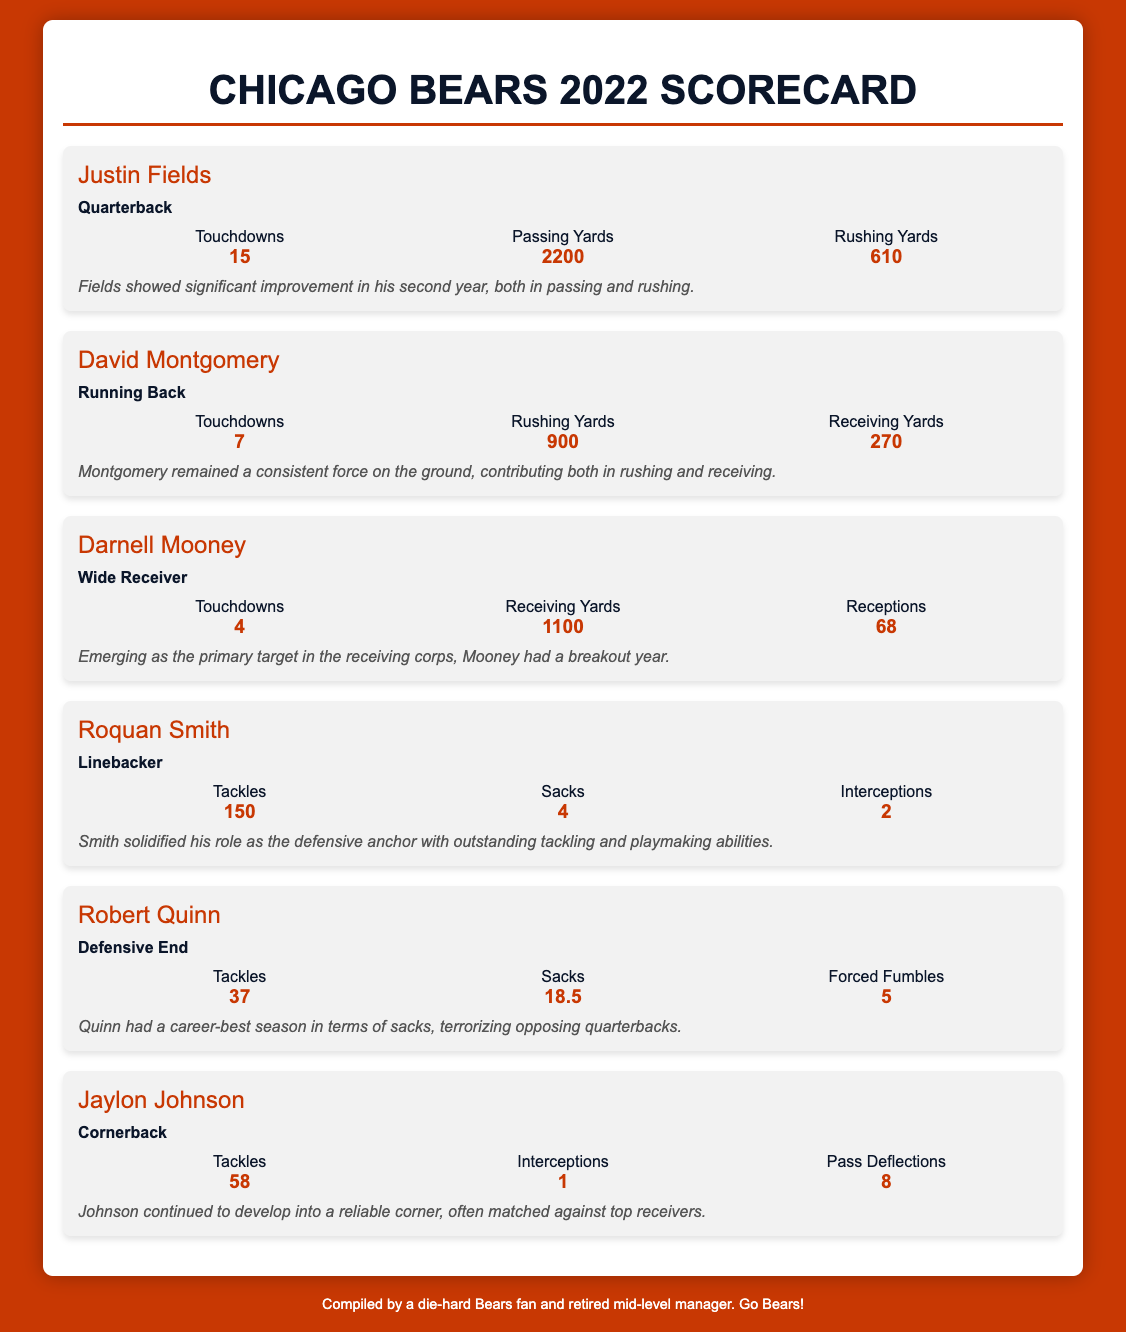What was Justin Fields' total number of touchdowns? The document states that Justin Fields scored 15 touchdowns during the 2022 season.
Answer: 15 How many tackles did Roquan Smith make? According to the metrics, Roquan Smith made 150 tackles in the season.
Answer: 150 Which player had the highest number of rushing yards? The metrics for Justin Fields show he had 610 rushing yards, while David Montgomery had 900 rushing yards, making Montgomerry the player with the most rushing yards.
Answer: 900 How many touchdowns did David Montgomery score? The scorecard indicates David Montgomery scored 7 touchdowns in the season.
Answer: 7 Who had more receiving yards, Darnell Mooney or David Montgomery? Darnell Mooney had 1100 receiving yards, while Montgomery had 270 receiving yards, indicating Mooney had more receiving yards.
Answer: Darnell Mooney How many sacks did Robert Quinn achieve in the 2022 season? The document specifies that Robert Quinn had 18.5 sacks during the season.
Answer: 18.5 What position does Jaylon Johnson play? The scorecard identifies Jaylon Johnson as a Cornerback.
Answer: Cornerback Which player had the note stating they terrorized opposing quarterbacks? The note regarding Robert Quinn mentions his ability to terrorize opposing quarterbacks during the season.
Answer: Robert Quinn How many interceptions did Jaylon Johnson have? The scorecard indicates that Jaylon Johnson had 1 interception in the season.
Answer: 1 